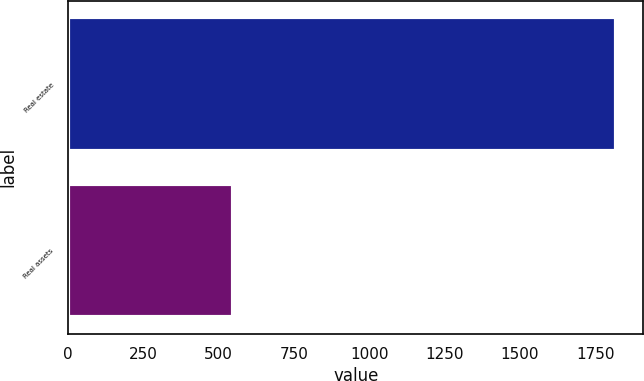Convert chart to OTSL. <chart><loc_0><loc_0><loc_500><loc_500><bar_chart><fcel>Real estate<fcel>Real assets<nl><fcel>1819<fcel>548<nl></chart> 